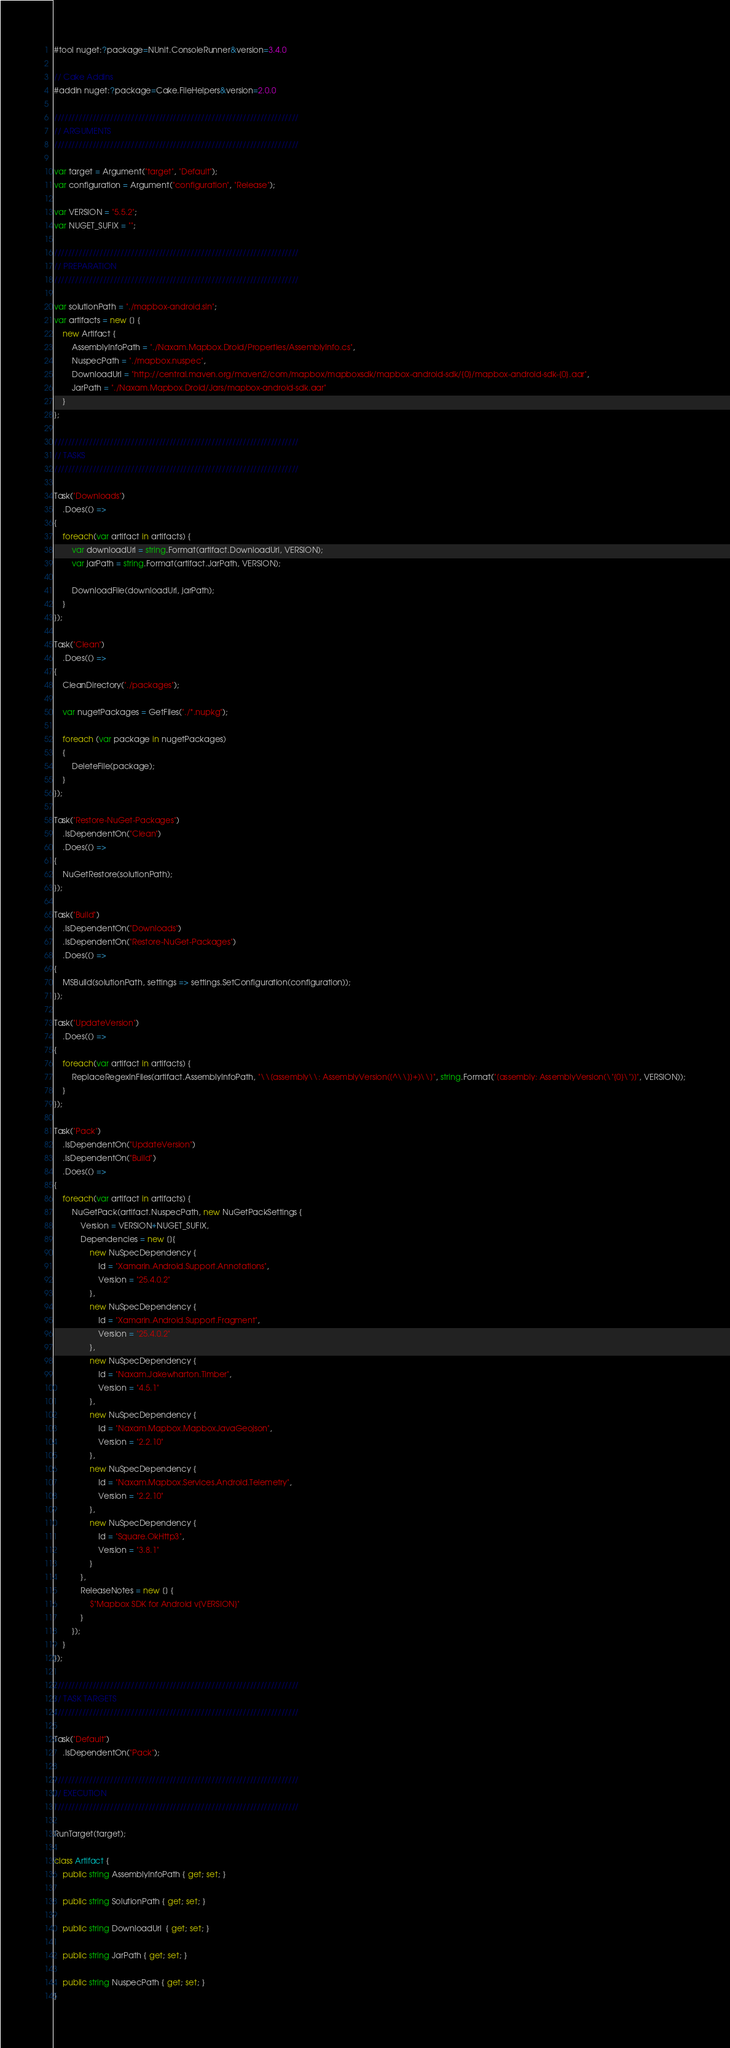Convert code to text. <code><loc_0><loc_0><loc_500><loc_500><_C#_>#tool nuget:?package=NUnit.ConsoleRunner&version=3.4.0

// Cake Addins
#addin nuget:?package=Cake.FileHelpers&version=2.0.0

//////////////////////////////////////////////////////////////////////
// ARGUMENTS
//////////////////////////////////////////////////////////////////////

var target = Argument("target", "Default");
var configuration = Argument("configuration", "Release");

var VERSION = "5.5.2";
var NUGET_SUFIX = "";

//////////////////////////////////////////////////////////////////////
// PREPARATION
//////////////////////////////////////////////////////////////////////

var solutionPath = "./mapbox-android.sln";
var artifacts = new [] {
    new Artifact {
        AssemblyInfoPath = "./Naxam.Mapbox.Droid/Properties/AssemblyInfo.cs",
        NuspecPath = "./mapbox.nuspec",
        DownloadUrl = "http://central.maven.org/maven2/com/mapbox/mapboxsdk/mapbox-android-sdk/{0}/mapbox-android-sdk-{0}.aar",
        JarPath = "./Naxam.Mapbox.Droid/Jars/mapbox-android-sdk.aar"
    }
};

//////////////////////////////////////////////////////////////////////
// TASKS
//////////////////////////////////////////////////////////////////////

Task("Downloads")
    .Does(() =>
{
    foreach(var artifact in artifacts) {
        var downloadUrl = string.Format(artifact.DownloadUrl, VERSION);
        var jarPath = string.Format(artifact.JarPath, VERSION);

        DownloadFile(downloadUrl, jarPath);
    }
});

Task("Clean")
    .Does(() =>
{
    CleanDirectory("./packages");

    var nugetPackages = GetFiles("./*.nupkg");

    foreach (var package in nugetPackages)
    {
        DeleteFile(package);
    }
});

Task("Restore-NuGet-Packages")
    .IsDependentOn("Clean")
    .Does(() =>
{
    NuGetRestore(solutionPath);
});

Task("Build")
    .IsDependentOn("Downloads")
    .IsDependentOn("Restore-NuGet-Packages")
    .Does(() =>
{
    MSBuild(solutionPath, settings => settings.SetConfiguration(configuration));
});

Task("UpdateVersion")
    .Does(() => 
{
    foreach(var artifact in artifacts) {
        ReplaceRegexInFiles(artifact.AssemblyInfoPath, "\\[assembly\\: AssemblyVersion([^\\]]+)\\]", string.Format("[assembly: AssemblyVersion(\"{0}\")]", VERSION));
    }
});

Task("Pack")
    .IsDependentOn("UpdateVersion")
    .IsDependentOn("Build")
    .Does(() =>
{
    foreach(var artifact in artifacts) {
        NuGetPack(artifact.NuspecPath, new NuGetPackSettings {
            Version = VERSION+NUGET_SUFIX,
            Dependencies = new []{
                new NuSpecDependency {
                    Id = "Xamarin.Android.Support.Annotations",
                    Version = "25.4.0.2"
                },
                new NuSpecDependency {
                    Id = "Xamarin.Android.Support.Fragment",
                    Version = "25.4.0.2"
                },
                new NuSpecDependency {
                    Id = "Naxam.Jakewharton.Timber",
                    Version = "4.5.1"
                },
                new NuSpecDependency {
                    Id = "Naxam.Mapbox.MapboxJavaGeojson",
                    Version = "2.2.10"
                },
                new NuSpecDependency {
                    Id = "Naxam.Mapbox.Services.Android.Telemetry",
                    Version = "2.2.10"
                },
                new NuSpecDependency {
                    Id = "Square.OkHttp3",
                    Version = "3.8.1"
                }
            },
            ReleaseNotes = new [] {
                $"Mapbox SDK for Android v{VERSION}"
            }
        });
    }
});

//////////////////////////////////////////////////////////////////////
// TASK TARGETS
//////////////////////////////////////////////////////////////////////

Task("Default")
    .IsDependentOn("Pack");

//////////////////////////////////////////////////////////////////////
// EXECUTION
//////////////////////////////////////////////////////////////////////

RunTarget(target);

class Artifact {
    public string AssemblyInfoPath { get; set; }

    public string SolutionPath { get; set; }

    public string DownloadUrl  { get; set; }

    public string JarPath { get; set; }

    public string NuspecPath { get; set; }
}</code> 